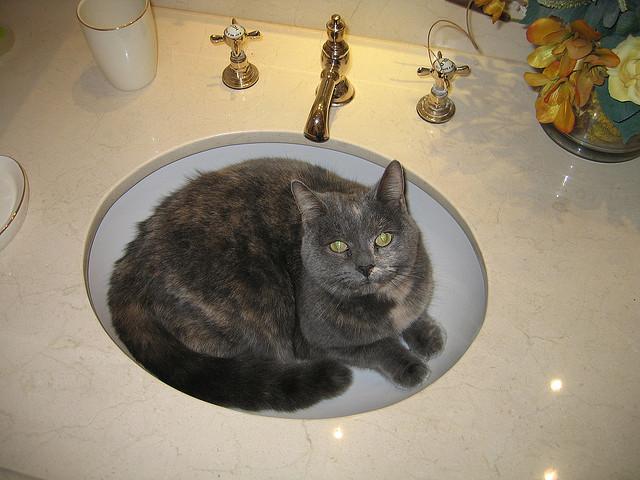What color is the cat?
Quick response, please. Gray. Is the cat awake?
Short answer required. Yes. What is the cat in?
Quick response, please. Sink. Where is this cat laying?
Concise answer only. Sink. 